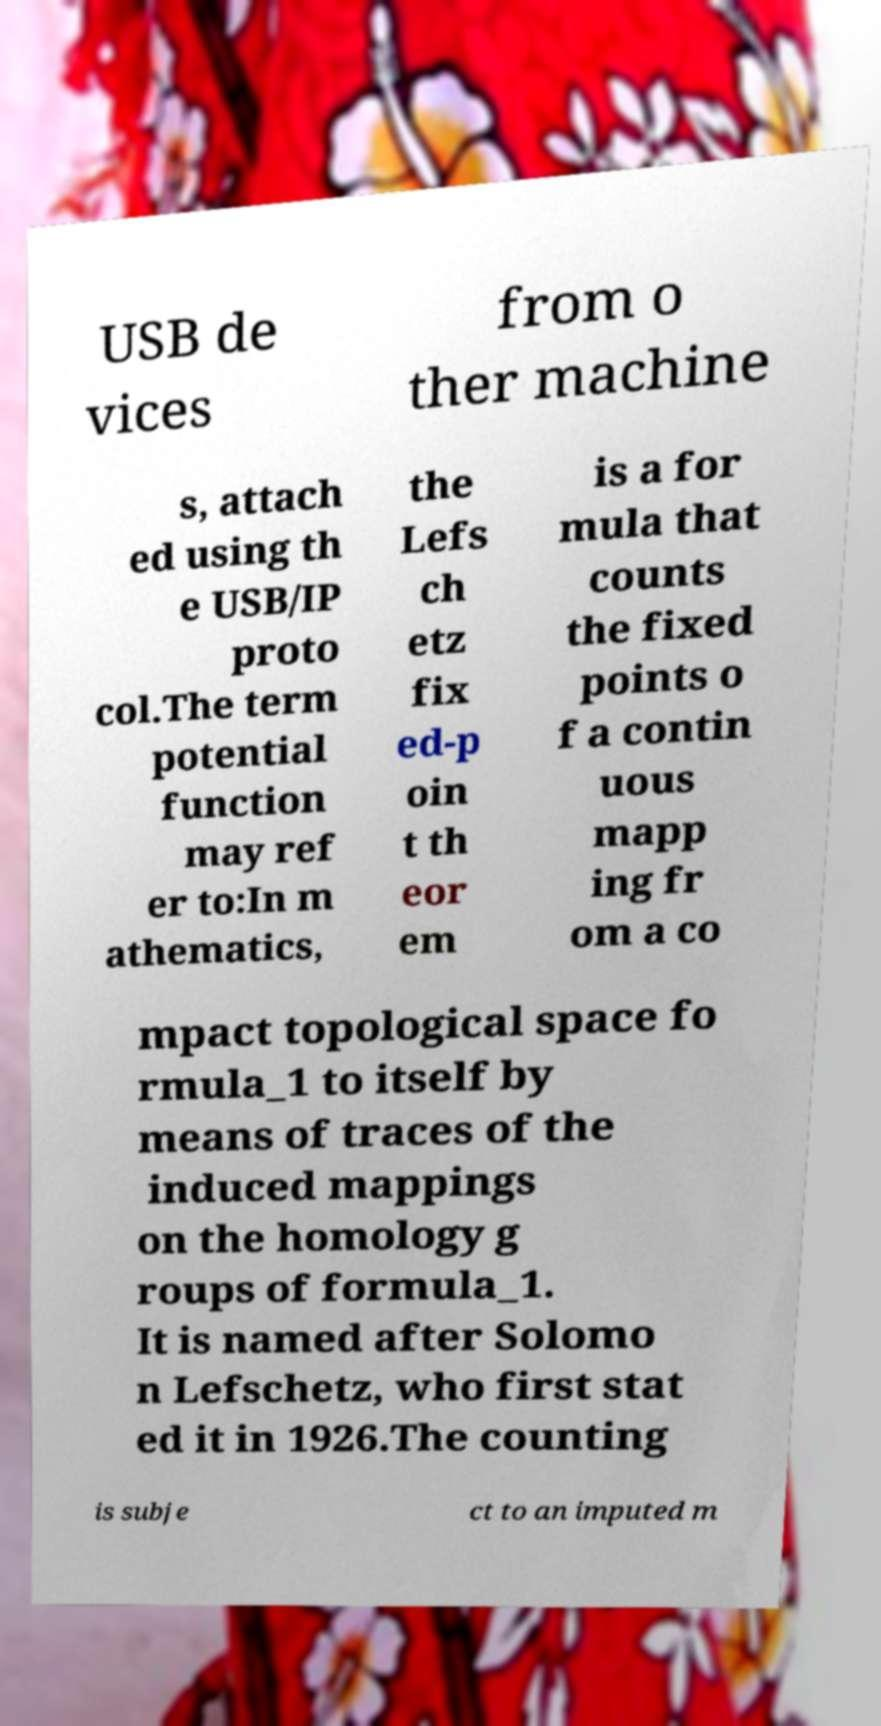There's text embedded in this image that I need extracted. Can you transcribe it verbatim? USB de vices from o ther machine s, attach ed using th e USB/IP proto col.The term potential function may ref er to:In m athematics, the Lefs ch etz fix ed-p oin t th eor em is a for mula that counts the fixed points o f a contin uous mapp ing fr om a co mpact topological space fo rmula_1 to itself by means of traces of the induced mappings on the homology g roups of formula_1. It is named after Solomo n Lefschetz, who first stat ed it in 1926.The counting is subje ct to an imputed m 